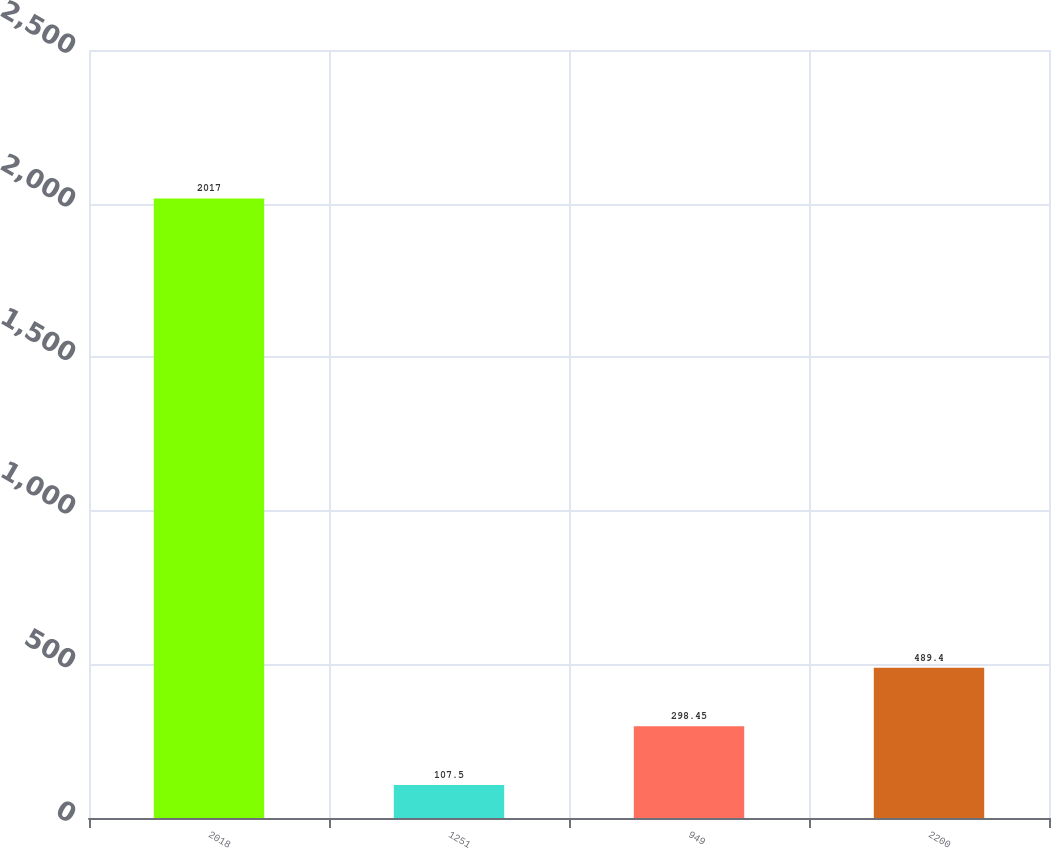<chart> <loc_0><loc_0><loc_500><loc_500><bar_chart><fcel>2018<fcel>1251<fcel>949<fcel>2200<nl><fcel>2017<fcel>107.5<fcel>298.45<fcel>489.4<nl></chart> 